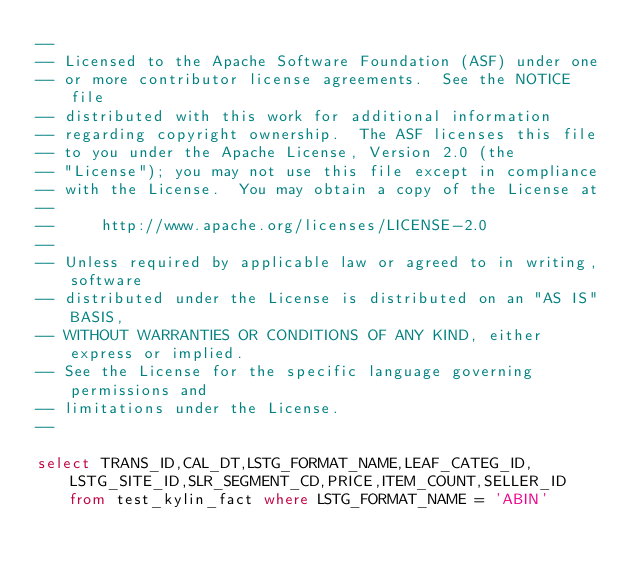<code> <loc_0><loc_0><loc_500><loc_500><_SQL_>--
-- Licensed to the Apache Software Foundation (ASF) under one
-- or more contributor license agreements.  See the NOTICE file
-- distributed with this work for additional information
-- regarding copyright ownership.  The ASF licenses this file
-- to you under the Apache License, Version 2.0 (the
-- "License"); you may not use this file except in compliance
-- with the License.  You may obtain a copy of the License at
--
--     http://www.apache.org/licenses/LICENSE-2.0
--
-- Unless required by applicable law or agreed to in writing, software
-- distributed under the License is distributed on an "AS IS" BASIS,
-- WITHOUT WARRANTIES OR CONDITIONS OF ANY KIND, either express or implied.
-- See the License for the specific language governing permissions and
-- limitations under the License.
--

select TRANS_ID,CAL_DT,LSTG_FORMAT_NAME,LEAF_CATEG_ID,LSTG_SITE_ID,SLR_SEGMENT_CD,PRICE,ITEM_COUNT,SELLER_ID from test_kylin_fact where LSTG_FORMAT_NAME = 'ABIN'
</code> 